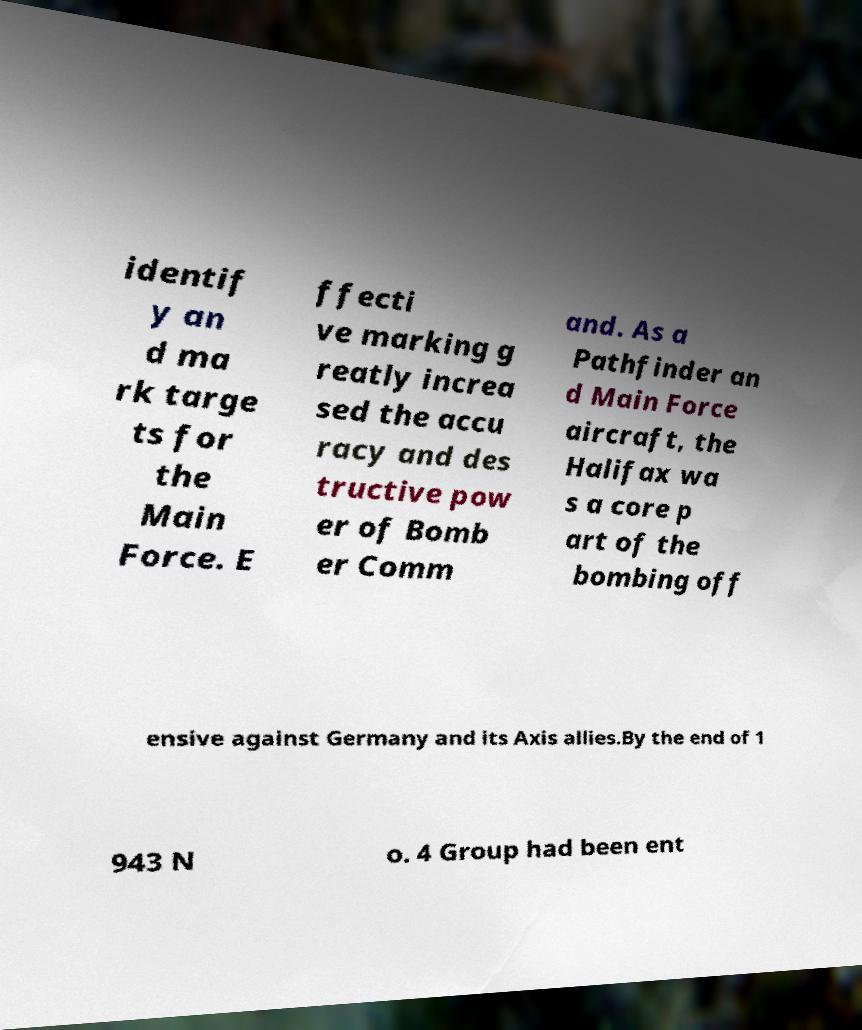Please identify and transcribe the text found in this image. identif y an d ma rk targe ts for the Main Force. E ffecti ve marking g reatly increa sed the accu racy and des tructive pow er of Bomb er Comm and. As a Pathfinder an d Main Force aircraft, the Halifax wa s a core p art of the bombing off ensive against Germany and its Axis allies.By the end of 1 943 N o. 4 Group had been ent 